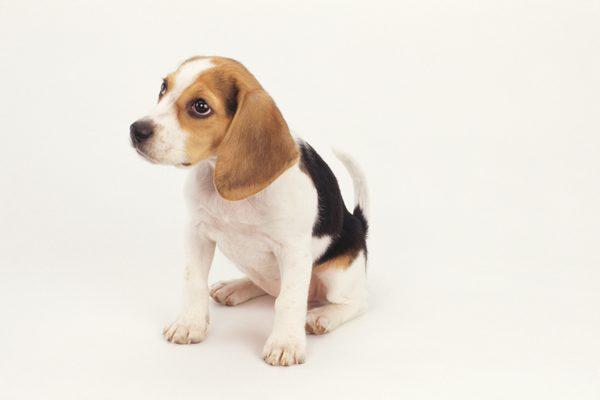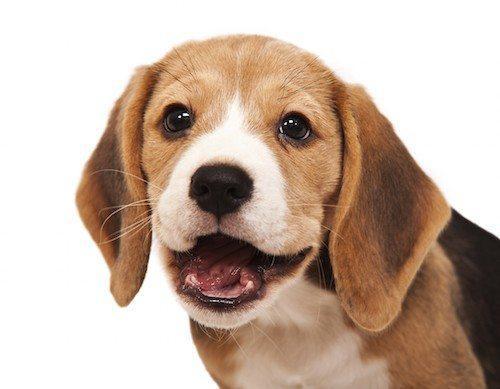The first image is the image on the left, the second image is the image on the right. For the images shown, is this caption "The dog is looking left, in the image to the left." true? Answer yes or no. Yes. The first image is the image on the left, the second image is the image on the right. For the images displayed, is the sentence "Two dogs are sitting." factually correct? Answer yes or no. No. 